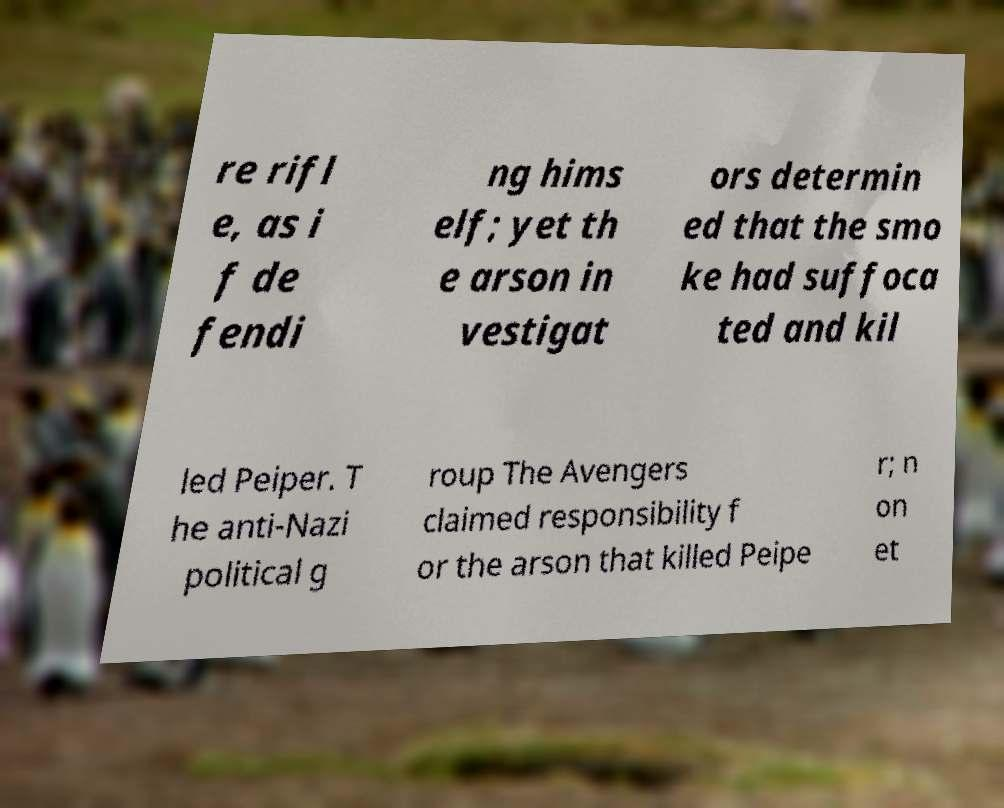I need the written content from this picture converted into text. Can you do that? re rifl e, as i f de fendi ng hims elf; yet th e arson in vestigat ors determin ed that the smo ke had suffoca ted and kil led Peiper. T he anti-Nazi political g roup The Avengers claimed responsibility f or the arson that killed Peipe r; n on et 